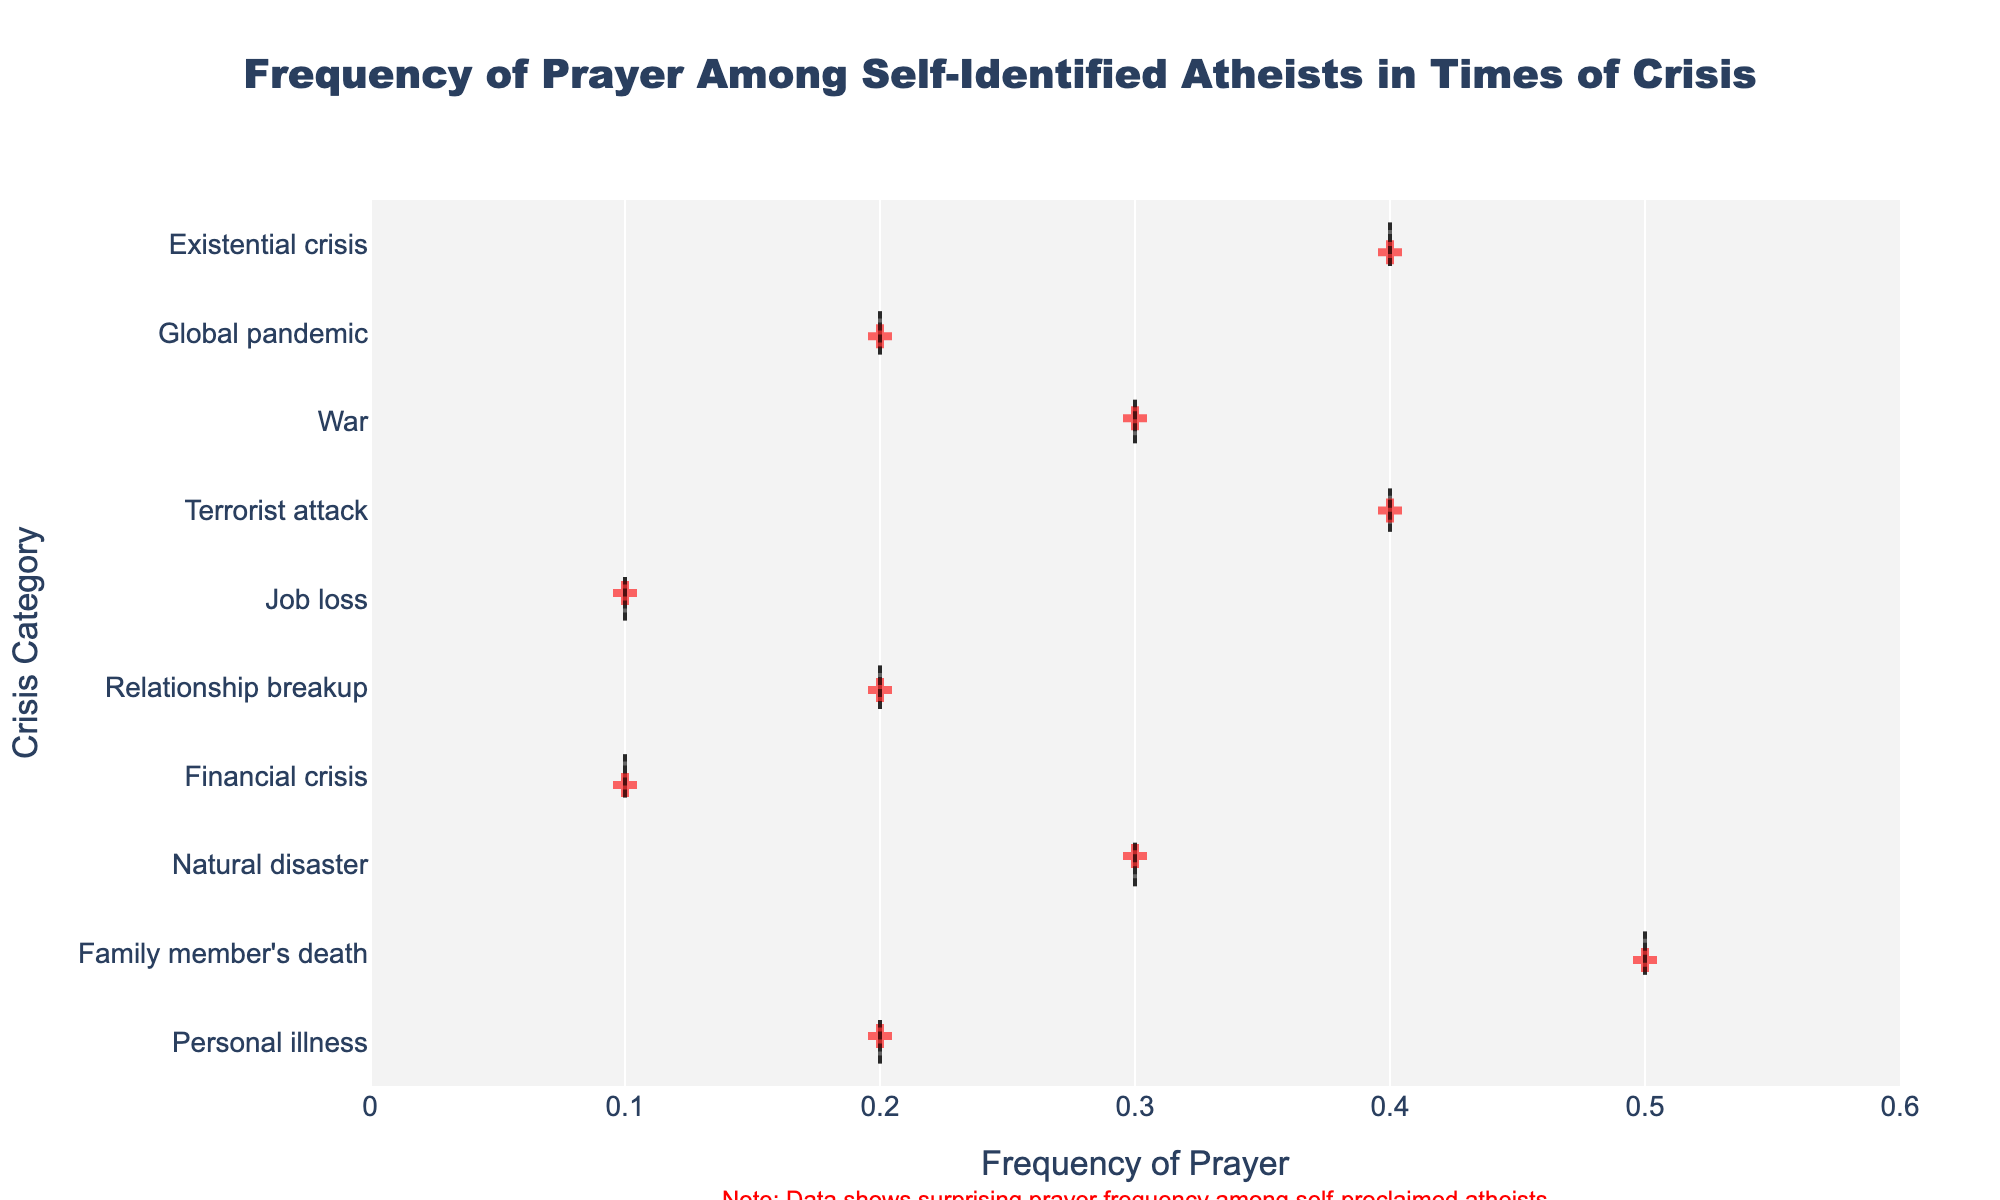Which crisis category shows the highest frequency of prayer among self-identified atheists? The strip plot displays the frequency of prayer for various crisis categories. By visually scanning the frequencies, it's clear that the category 'Family member's death' has the highest frequency, which is 0.5.
Answer: Family member's death What is the range of frequencies observed in the figure? The range is calculated by subtracting the lowest frequency from the highest frequency. From the strip plot, the lowest frequency is 0.1 (financial crisis, job loss) and the highest is 0.5 (family member's death), so the range is 0.5 - 0.1 = 0.4.
Answer: 0.4 Which two crisis categories have the same frequency of prayer? Scanning the plot, both 'Personal illness' and 'Relationship breakup' share the same frequency of 0.2. Similarly, 'Financial crisis' and 'Job loss' also share the same frequency of 0.1.
Answer: Personal illness and Relationship breakup; Financial crisis and Job loss What is the average frequency of prayer for the categories ‘Natural disaster,’ ‘Terrorist attack,’ and ‘War?’ To find the average, add the frequencies for these categories and divide by the number of categories: (0.3 + 0.4 + 0.3) / 3 = 1.0 / 3 ≈ 0.33.
Answer: 0.33 Is the frequency of prayer higher for 'Natural disaster' or 'Existential crisis?' Comparing the two categories, 'Existential crisis' has a frequency of 0.4, while 'Natural disaster' has a frequency of 0.3. Thus, 'Existential crisis' is higher.
Answer: Existential crisis What does the annotation at the bottom of the plot indicate? The annotation at the bottom of the plot notes that the data shows a surprising frequency of prayer among self-proclaimed atheists, possibly hinting that these situations lead even non-believers to seek comfort in prayer.
Answer: Prayer frequency surprising among atheists Compare the frequency of prayer in 'Global pandemic' and 'Personal illness.' Which is higher? The figure shows that both 'Global pandemic' and 'Personal illness' have the same frequency of 0.2. Therefore, neither is higher.
Answer: Neither; they are equal Calculate the midpoint between the highest and lowest frequencies. The highest frequency is 0.5 and the lowest is 0.1. The midpoint is (0.5 + 0.1) / 2 = 0.3.
Answer: 0.3 Does any category have a frequency of 0.4? If so, name them. Looking at the plot, the categories 'Terrorist attack' and 'Existential crisis' both have a frequency of 0.4.
Answer: Terrorist attack and Existential crisis How often did 'Relationship breakup' and 'Job loss' categories report prayer compared to 'War'? 'Relationship breakup' and 'Job loss' have frequencies of 0.2 and 0.1, respectively, while 'War' has a frequency of 0.3. This means both are less frequent in prayer compared to 'War.'
Answer: Less frequent 